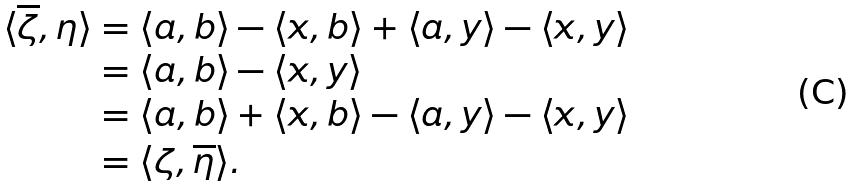Convert formula to latex. <formula><loc_0><loc_0><loc_500><loc_500>\langle \overline { \zeta } , \eta \rangle & = \langle a , b \rangle - \langle x , b \rangle + \langle a , y \rangle - \langle x , y \rangle \\ & = \langle a , b \rangle - \langle x , y \rangle \\ & = \langle a , b \rangle + \langle x , b \rangle - \langle a , y \rangle - \langle x , y \rangle \\ & = \langle \zeta , \overline { \eta } \rangle .</formula> 